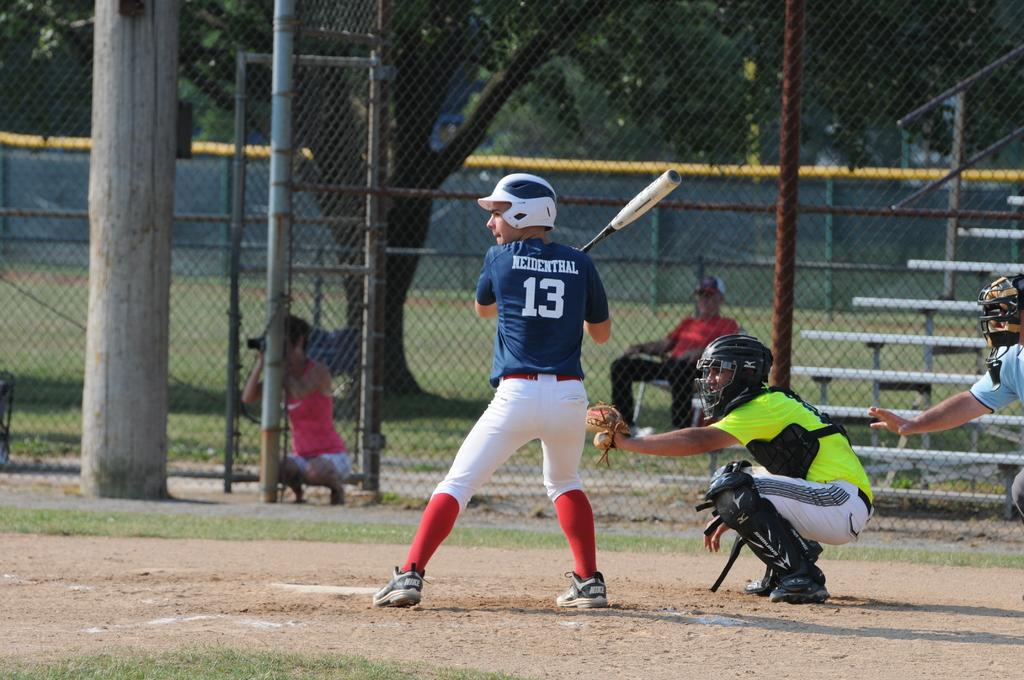What is the batter's number?
Offer a very short reply. 13. 